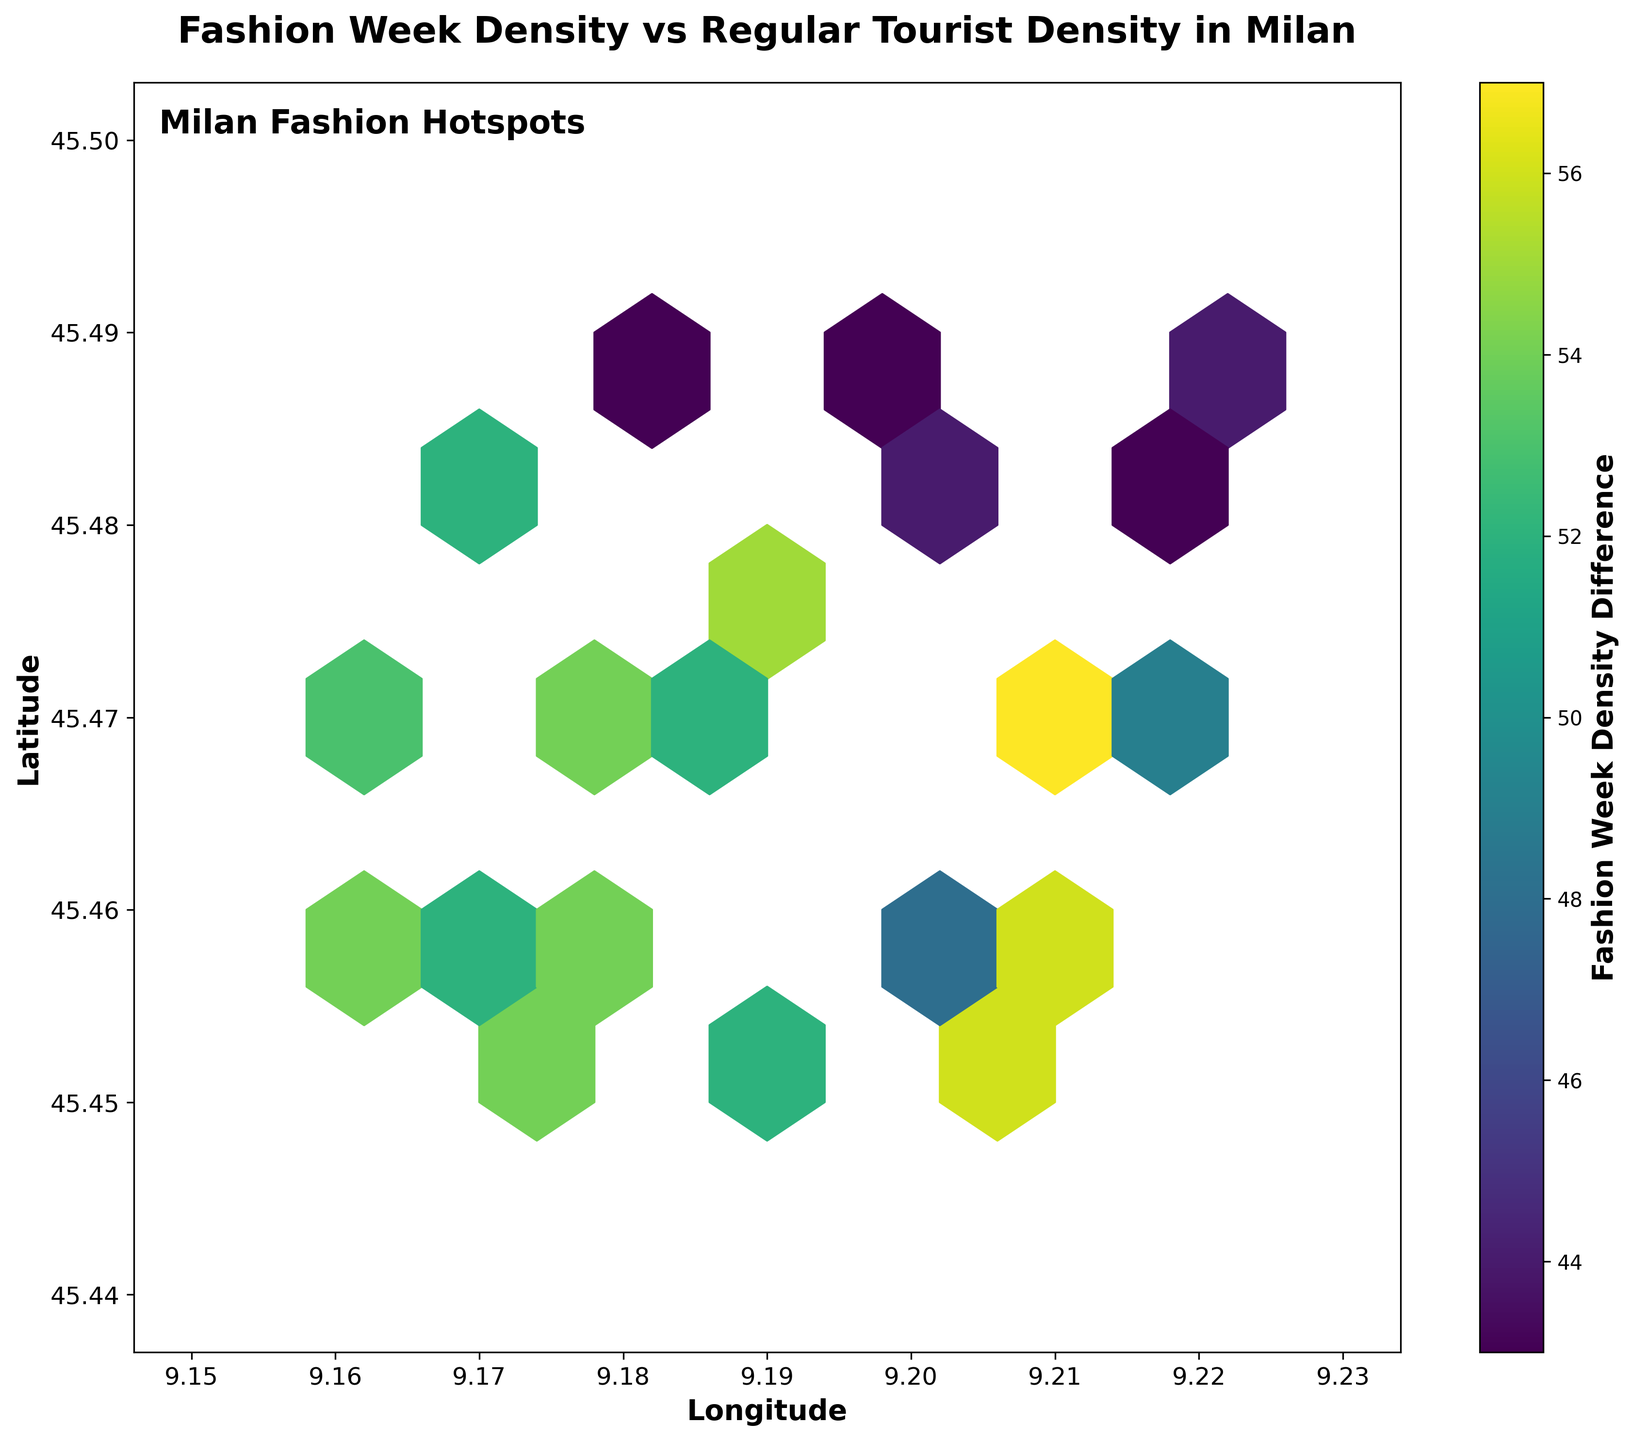What is the title of the plot? The title is usually placed at the top of the plot in a bold font for easy visibility. Here, the title is "Fashion Week Density vs Regular Tourist Density in Milan".
Answer: Fashion Week Density vs Regular Tourist Density in Milan What is the label of the colorbar? The label of the colorbar can be found next to the color gradient bar, explaining what the colors represent. In this figure, the label is "Fashion Week Density Difference".
Answer: Fashion Week Density Difference What are the units used on the x-axis and y-axis? By looking at the axis labels, one can see that the x-axis represents "Longitude" and the y-axis represents "Latitude".
Answer: Longitude and Latitude What does the color in the hexbin plot represent? The color in the hexbin plot indicates the density difference between Fashion Week attendees and regular tourists. Darker shades represent larger differences.
Answer: Density difference Which Milanese district has the highest density difference? By observing the darkest hexagons on the plot, it can be inferred that the district around coordinates (9.21, 45.47) shows the highest density difference.
Answer: Around (9.21, 45.47) How do the densities of Fashion Week attendees and regular tourists differ? The visual gradient and the colorbar indicate that there are pockets where the density of Fashion Week attendees significantly exceeds that of regular tourists, implying high interest in those areas.
Answer: Higher in certain districts during Fashion Week Which coordinate shows a similar density for both Fashion Week attendees and regular tourists? By examining the areas with lighter shades, we can find coordinates around (9.18, 45.49) indicating similar densities due to minimal color difference.
Answer: Around (9.18, 45.49) Are there more attendees during Fashion Week compared to regular tourists across all districts? The color gradient overall is on the darker side for most hexagons, suggesting that the density of Fashion Week attendees is generally higher than that of regular tourists across most districts.
Answer: Yes Which coordinate has a negative or zero difference in density? By looking at the color gradient associated with negative or zero density differences (lighter colors or near the base of the colorbar), you can identify the coordinate around (9.18, 45.49), indicating minimal or zero difference.
Answer: Around (9.18, 45.49) What is the density difference at the coordinate (9.17, 45.46)? Counting from the color gradient, the value at (9.17, 45.46) lies towards the darker side, indicating a positive difference. The exact value would hinge on detailed analysis, but it is significantly positive.
Answer: Positive and significantly higher 